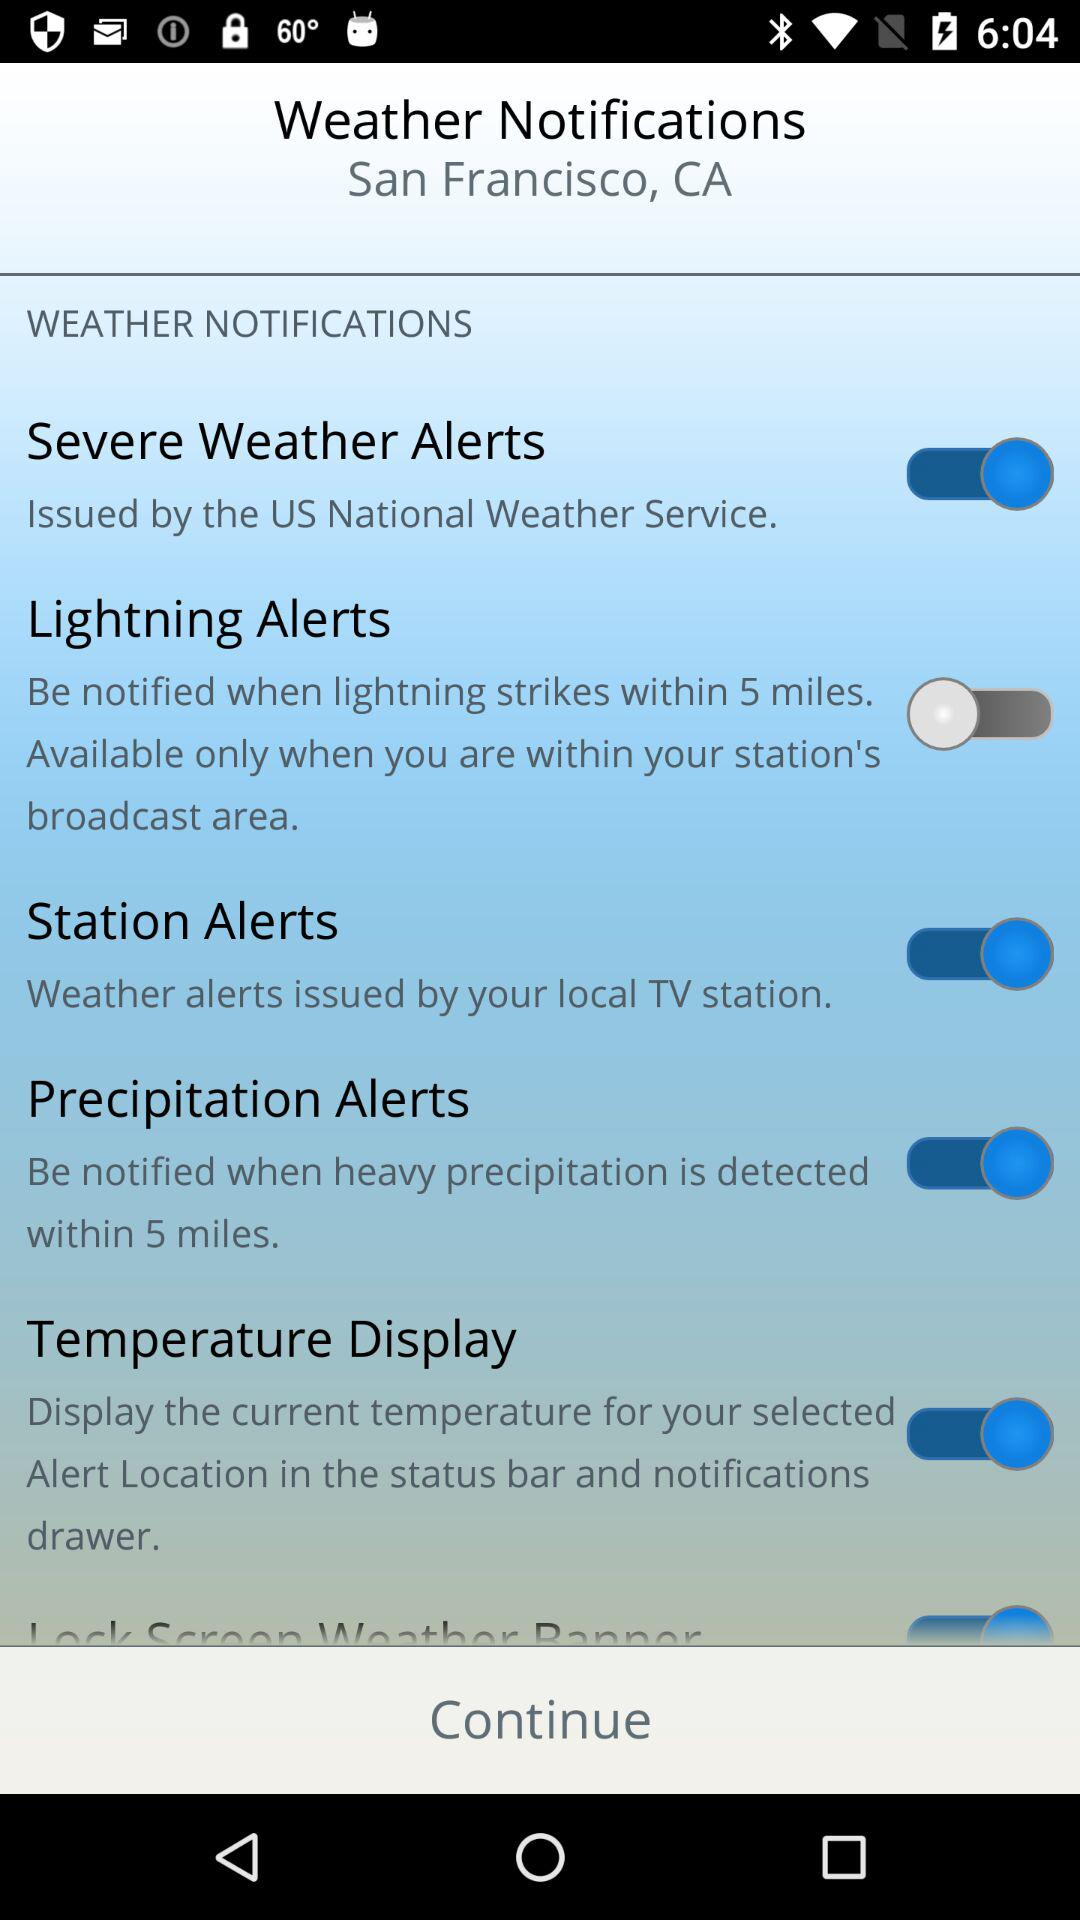What is the status of "Severe Weather Alerts"? The status of "Severe Weather Alerts" is "on". 